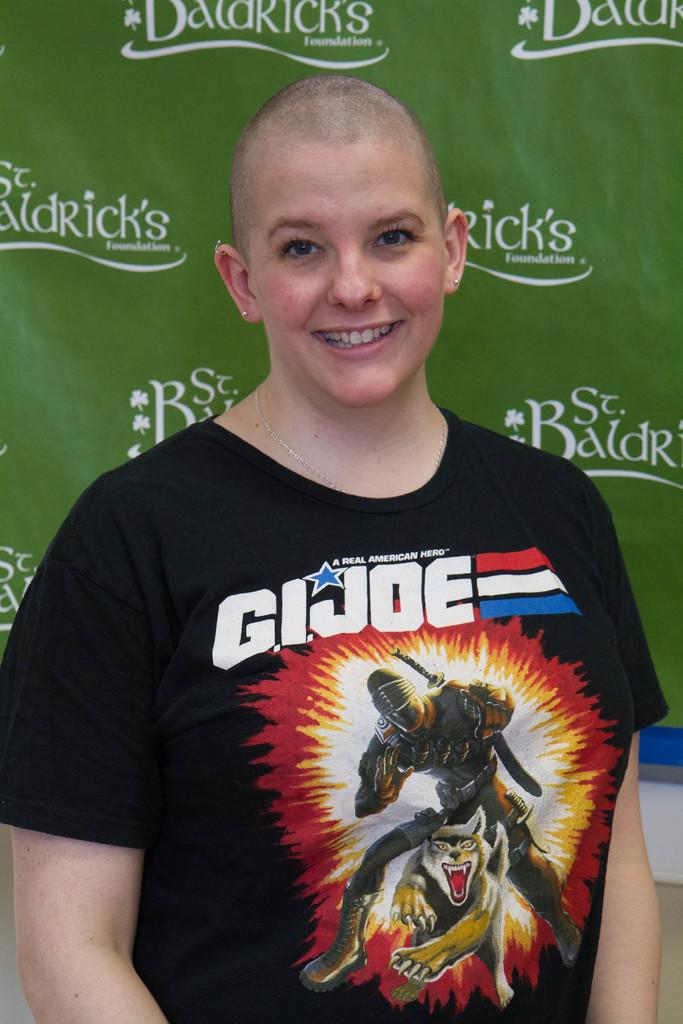Who is present in the image? A: There is a woman in the image. What is the woman doing in the image? The woman is smiling in the image. What can be seen in the background of the image? There is an advertisement in the background of the image. What type of fork can be seen in the woman's hand in the image? There is no fork present in the image; the woman is not holding anything. 